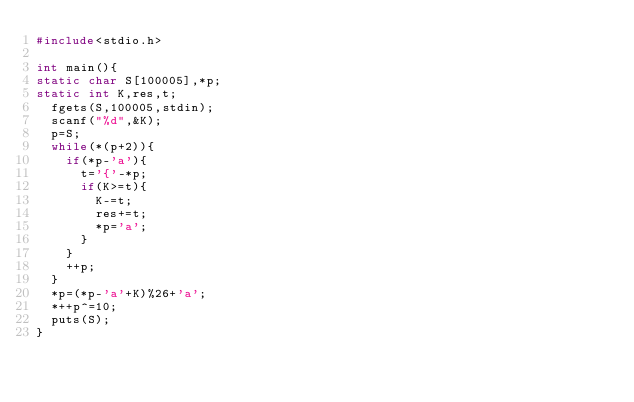<code> <loc_0><loc_0><loc_500><loc_500><_C_>#include<stdio.h>

int main(){
static char S[100005],*p;
static int K,res,t;
  fgets(S,100005,stdin);
  scanf("%d",&K);
  p=S;
  while(*(p+2)){
    if(*p-'a'){
      t='{'-*p;
      if(K>=t){
        K-=t;
        res+=t;
        *p='a';
      }
    }
    ++p;
  }
  *p=(*p-'a'+K)%26+'a';
  *++p^=10;
  puts(S);
}</code> 